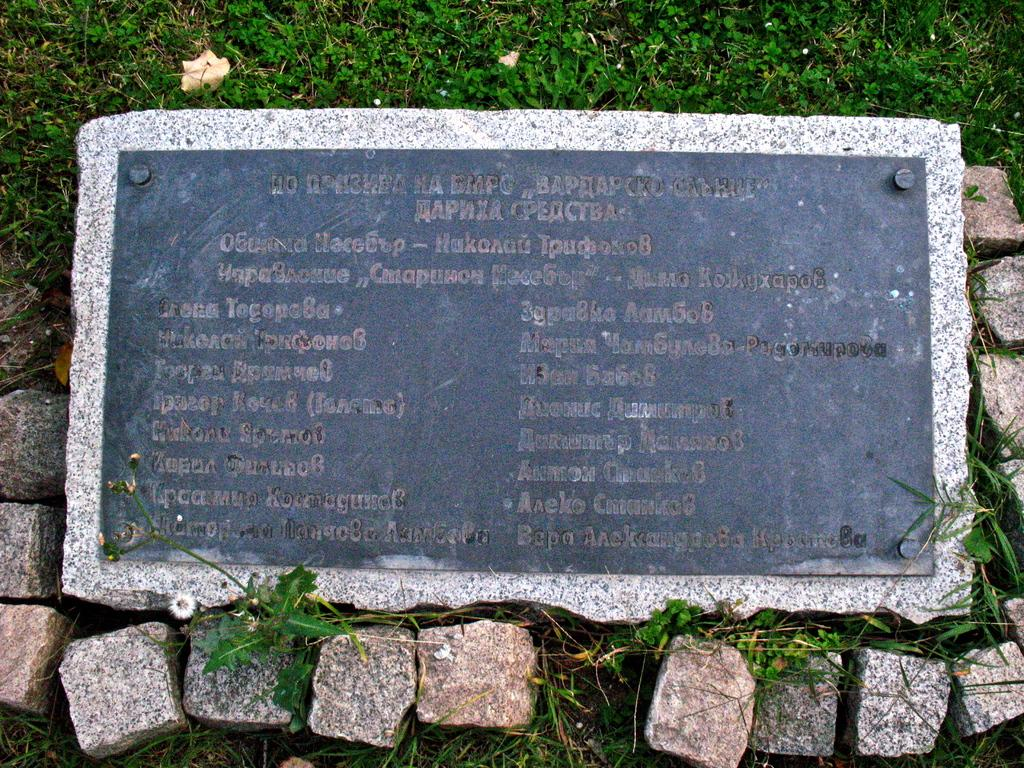What is the main object in the image? There is a stone board with text in the image. Where is the stone board located? The stone board is placed on the grass. Are there any other stones visible in the image? Yes, there are stones present in the image. What type of apparel is the grass wearing in the image? The grass is not wearing any apparel, as it is a natural element and not a living being. How many cherries can be seen on the stone board in the image? There are no cherries present on the stone board or in the image. 